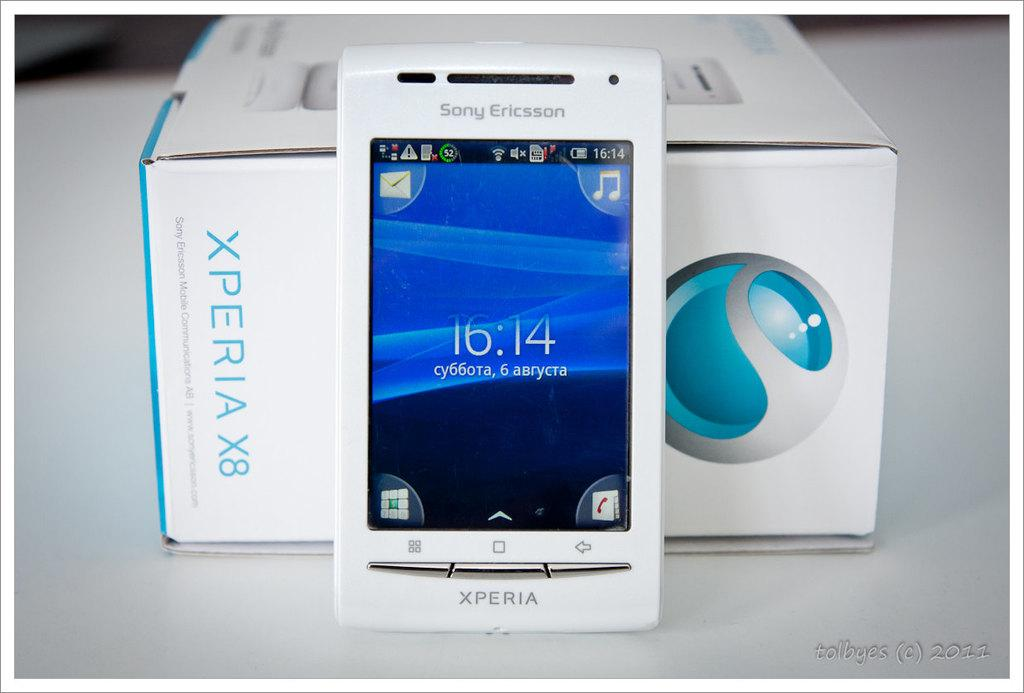What electronic device is visible in the image? There is a mobile phone in the image. What other object can be seen in the image? There is a box in the image. Can you describe the background of the image? The background of the image is blurry. What is present at the bottom right corner of the image? There is some text at the bottom right corner of the image. What type of gold is being stored in the cellar in the image? There is no mention of gold or a cellar in the image; it only features a mobile phone and a box with a blurry background and some text at the bottom right corner. 